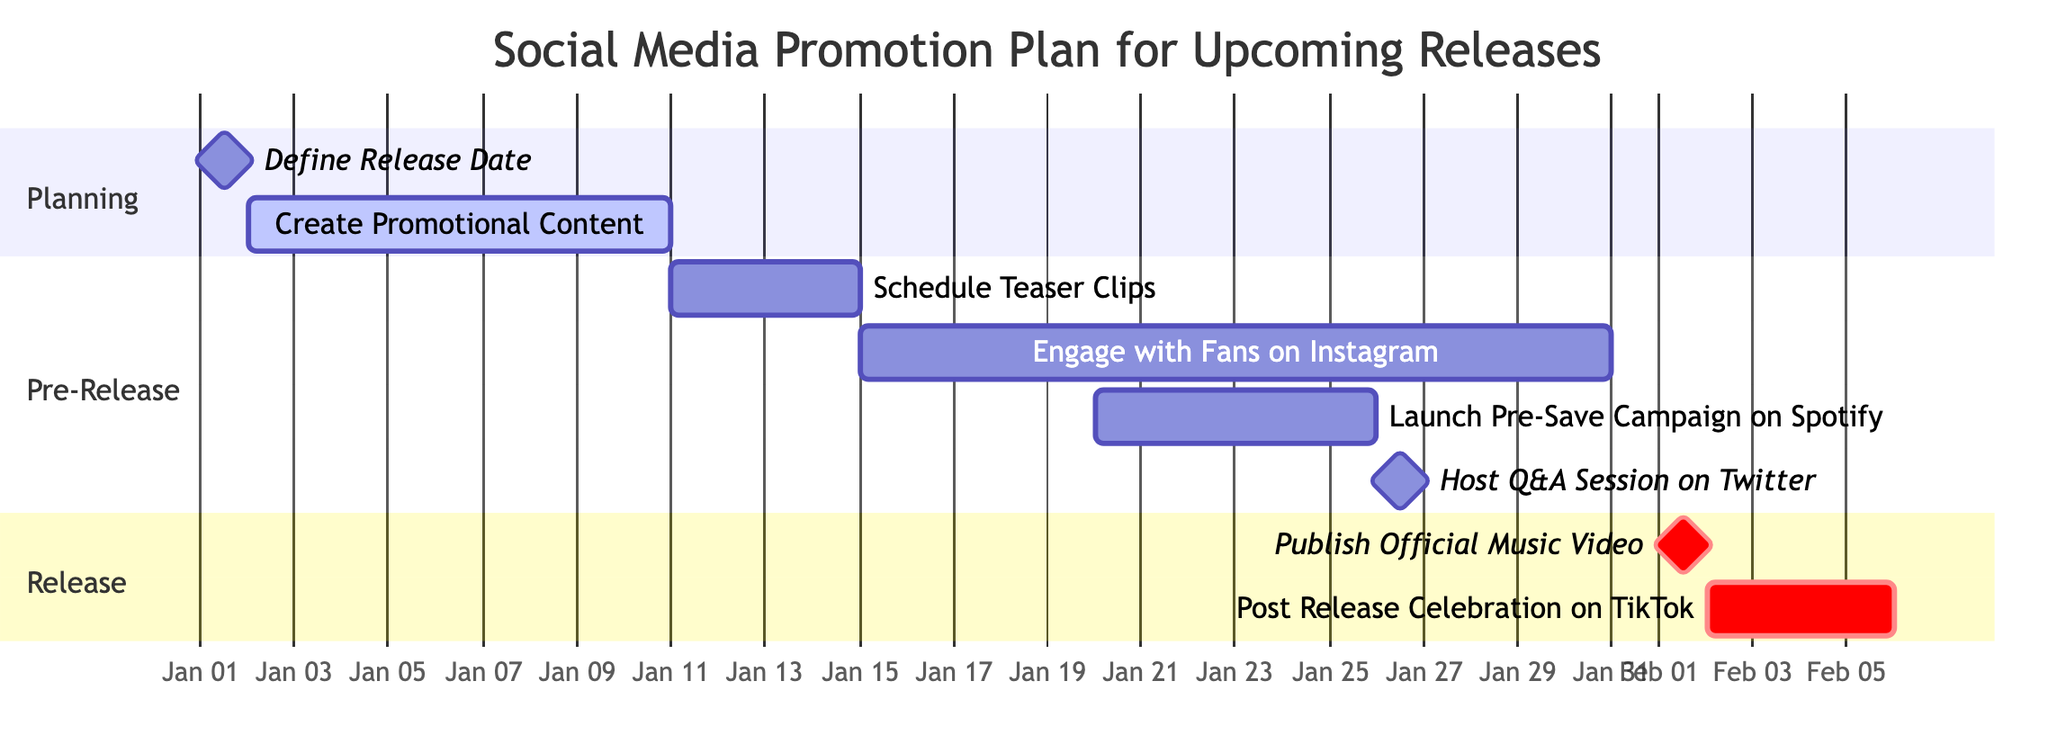What is the start date for the "Schedule Teaser Clips" task? The "Schedule Teaser Clips" task begins on January 11, 2024, as indicated in the Gantt chart where each task is listed alongside its respective start and end dates.
Answer: January 11, 2024 How many days does the "Create Promotional Content" task take? The "Create Promotional Content" task starts on January 2, 2024, and ends on January 10, 2024. Counting the days from start to end gives a total of 9 days.
Answer: 9 days What task is scheduled immediately after the "Define Release Date"? "Create Promotional Content" is the task scheduled immediately after "Define Release Date," as it follows directly in the timeline after its completion.
Answer: Create Promotional Content How many tasks are in the "Pre-Release" section? The "Pre-Release" section contains four tasks: "Schedule Teaser Clips," "Engage with Fans on Instagram," "Launch Pre-Save Campaign on Spotify," and "Host Q&A Session on Twitter." Counting these tasks gives a total of four.
Answer: 4 What is the end date of the "Post Release Celebration on TikTok"? The "Post Release Celebration on TikTok" task ends on February 5, 2024, as detailed in the Gantt chart that lists each task’s duration up to its end date.
Answer: February 5, 2024 Which task is marked as critical in the release section? "Publish Official Music Video" is marked as critical in the release section, indicated by the designation given next to the task in the Gantt chart.
Answer: Publish Official Music Video What is the total duration of the "Engage with Fans on Instagram" task? The "Engage with Fans on Instagram" task starts on January 15, 2024, and ends on January 30, 2024. Calculating the range of days gives a total duration of 16 days.
Answer: 16 days Is "Launch Pre-Save Campaign on Spotify" scheduled before or after "Host Q&A Session on Twitter"? "Launch Pre-Save Campaign on Spotify" is scheduled before "Host Q&A Session on Twitter," as its end date of January 25, 2024, precedes the January 26, 2024 date when the Q&A session occurs.
Answer: Before What is the task that immediately follows the "Publish Official Music Video"? The task that follows "Publish Official Music Video" is "Post Release Celebration on TikTok," starting on February 2, 2024, the day after the music video is published.
Answer: Post Release Celebration on TikTok 